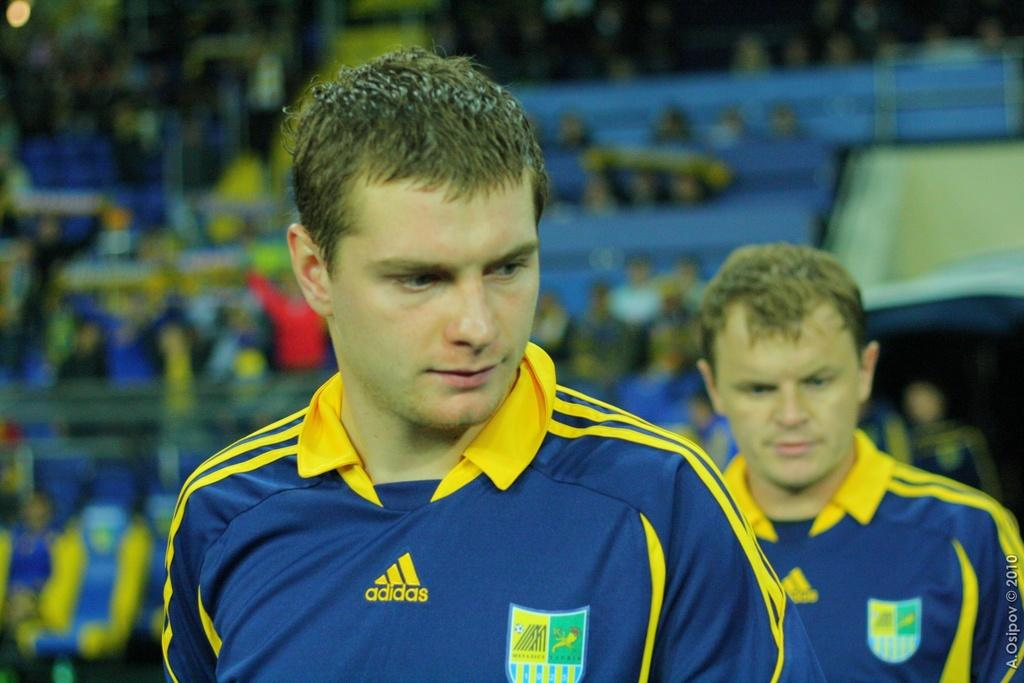What can be observed about the background of the image? The background of the picture is blurry. Who is present in the image? There are people in the image, including men. Can you describe any specific features or elements in the image? There is a watermark in the bottom right corner of the picture. What suggestion does the boy in the image make to the others? There is no boy present in the image, only men. How does the watermark in the image make the people feel ashamed? The watermark does not make anyone feel ashamed, as it is a common feature in images and does not have any emotional impact on the people in the image. 